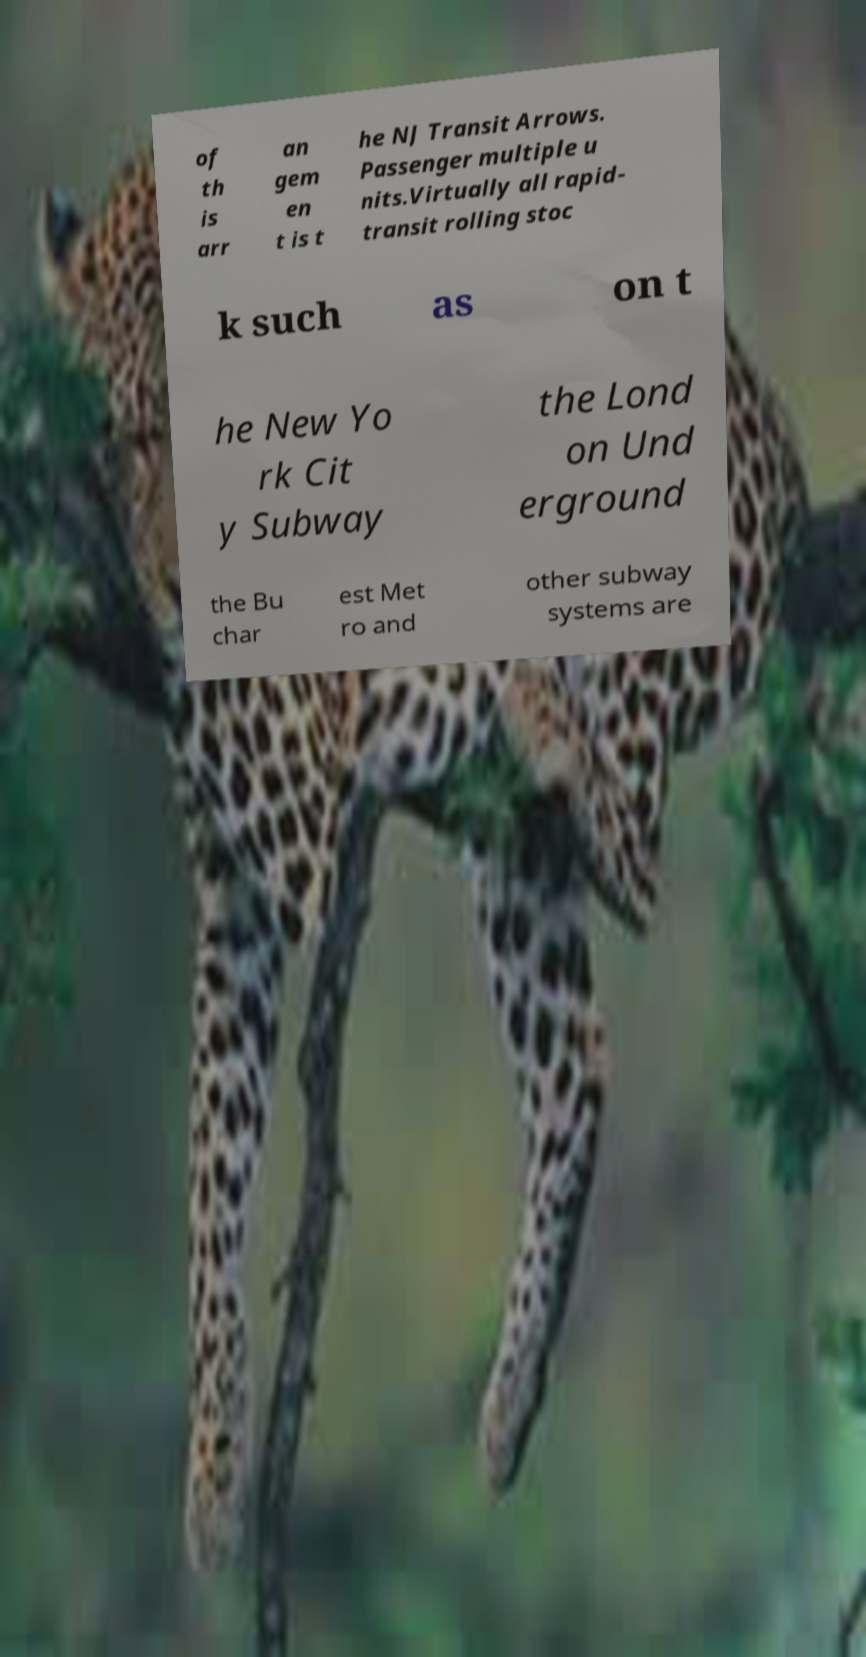Please read and relay the text visible in this image. What does it say? of th is arr an gem en t is t he NJ Transit Arrows. Passenger multiple u nits.Virtually all rapid- transit rolling stoc k such as on t he New Yo rk Cit y Subway the Lond on Und erground the Bu char est Met ro and other subway systems are 